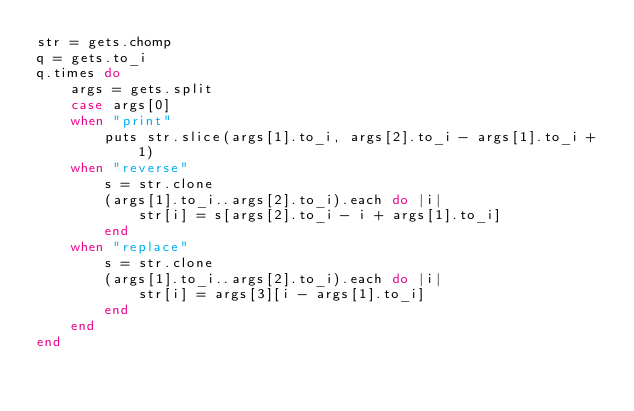<code> <loc_0><loc_0><loc_500><loc_500><_Ruby_>str = gets.chomp
q = gets.to_i
q.times do
	args = gets.split
	case args[0]
	when "print"
		puts str.slice(args[1].to_i, args[2].to_i - args[1].to_i + 1)
	when "reverse"
		s = str.clone
		(args[1].to_i..args[2].to_i).each do |i|
			str[i] = s[args[2].to_i - i + args[1].to_i]
		end
	when "replace"
		s = str.clone
		(args[1].to_i..args[2].to_i).each do |i|
			str[i] = args[3][i - args[1].to_i]
		end
	end
end</code> 